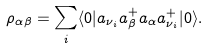Convert formula to latex. <formula><loc_0><loc_0><loc_500><loc_500>\rho _ { \alpha \beta } = \sum _ { i } \langle 0 | a _ { \nu _ { i } } a _ { \beta } ^ { + } a _ { \alpha } a _ { \nu _ { i } } ^ { + } | 0 \rangle .</formula> 